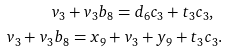<formula> <loc_0><loc_0><loc_500><loc_500>v _ { 3 } + v _ { 3 } b _ { 8 } = d _ { 6 } c _ { 3 } + t _ { 3 } c _ { 3 } , \ \\ v _ { 3 } + v _ { 3 } b _ { 8 } = x _ { 9 } + v _ { 3 } + y _ { 9 } + t _ { 3 } c _ { 3 } .</formula> 